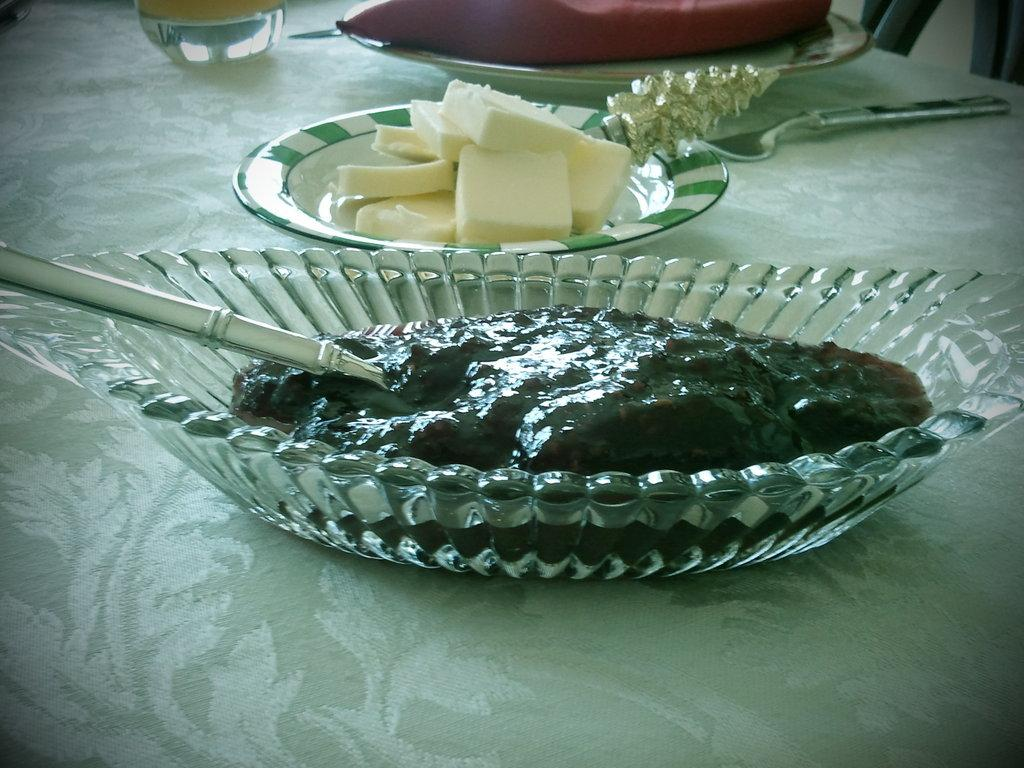What is present in the image related to food? There is food in the image. Where is the food located? The food is on a table. What utensils are visible in the image? There are spoons in the image. What type of secretary can be seen working with the food in the image? There is no secretary present in the image; it only features food on a table and spoons. Can you tell me how many dinosaurs are visible in the image? There are no dinosaurs present in the image. 